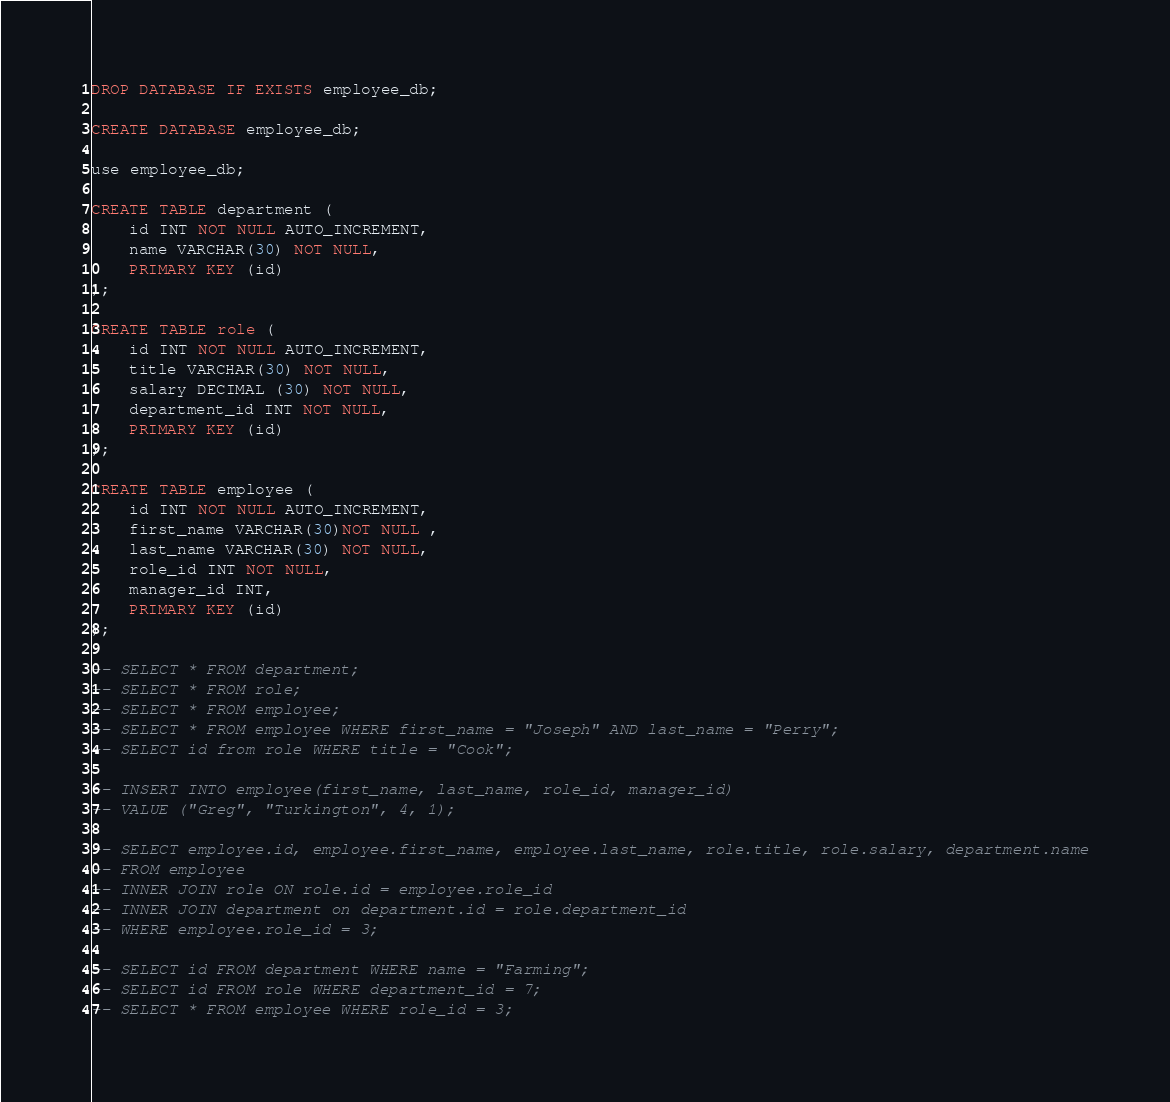<code> <loc_0><loc_0><loc_500><loc_500><_SQL_>DROP DATABASE IF EXISTS employee_db;

CREATE DATABASE employee_db;

use employee_db;

CREATE TABLE department (
	id INT NOT NULL AUTO_INCREMENT,
    name VARCHAR(30) NOT NULL,
    PRIMARY KEY (id)
);

CREATE TABLE role (
	id INT NOT NULL AUTO_INCREMENT,
    title VARCHAR(30) NOT NULL,
    salary DECIMAL (30) NOT NULL,
    department_id INT NOT NULL,
    PRIMARY KEY (id)
);

CREATE TABLE employee (
	id INT NOT NULL AUTO_INCREMENT,
    first_name VARCHAR(30)NOT NULL ,
    last_name VARCHAR(30) NOT NULL,
    role_id INT NOT NULL,
    manager_id INT,
    PRIMARY KEY (id)
);

-- SELECT * FROM department;
-- SELECT * FROM role;
-- SELECT * FROM employee;
-- SELECT * FROM employee WHERE first_name = "Joseph" AND last_name = "Perry";
-- SELECT id from role WHERE title = "Cook";

-- INSERT INTO employee(first_name, last_name, role_id, manager_id)
-- VALUE ("Greg", "Turkington", 4, 1);

-- SELECT employee.id, employee.first_name, employee.last_name, role.title, role.salary, department.name
-- FROM employee
-- INNER JOIN role ON role.id = employee.role_id
-- INNER JOIN department on department.id = role.department_id
-- WHERE employee.role_id = 3;

-- SELECT id FROM department WHERE name = "Farming";
-- SELECT id FROM role WHERE department_id = 7;
-- SELECT * FROM employee WHERE role_id = 3;</code> 